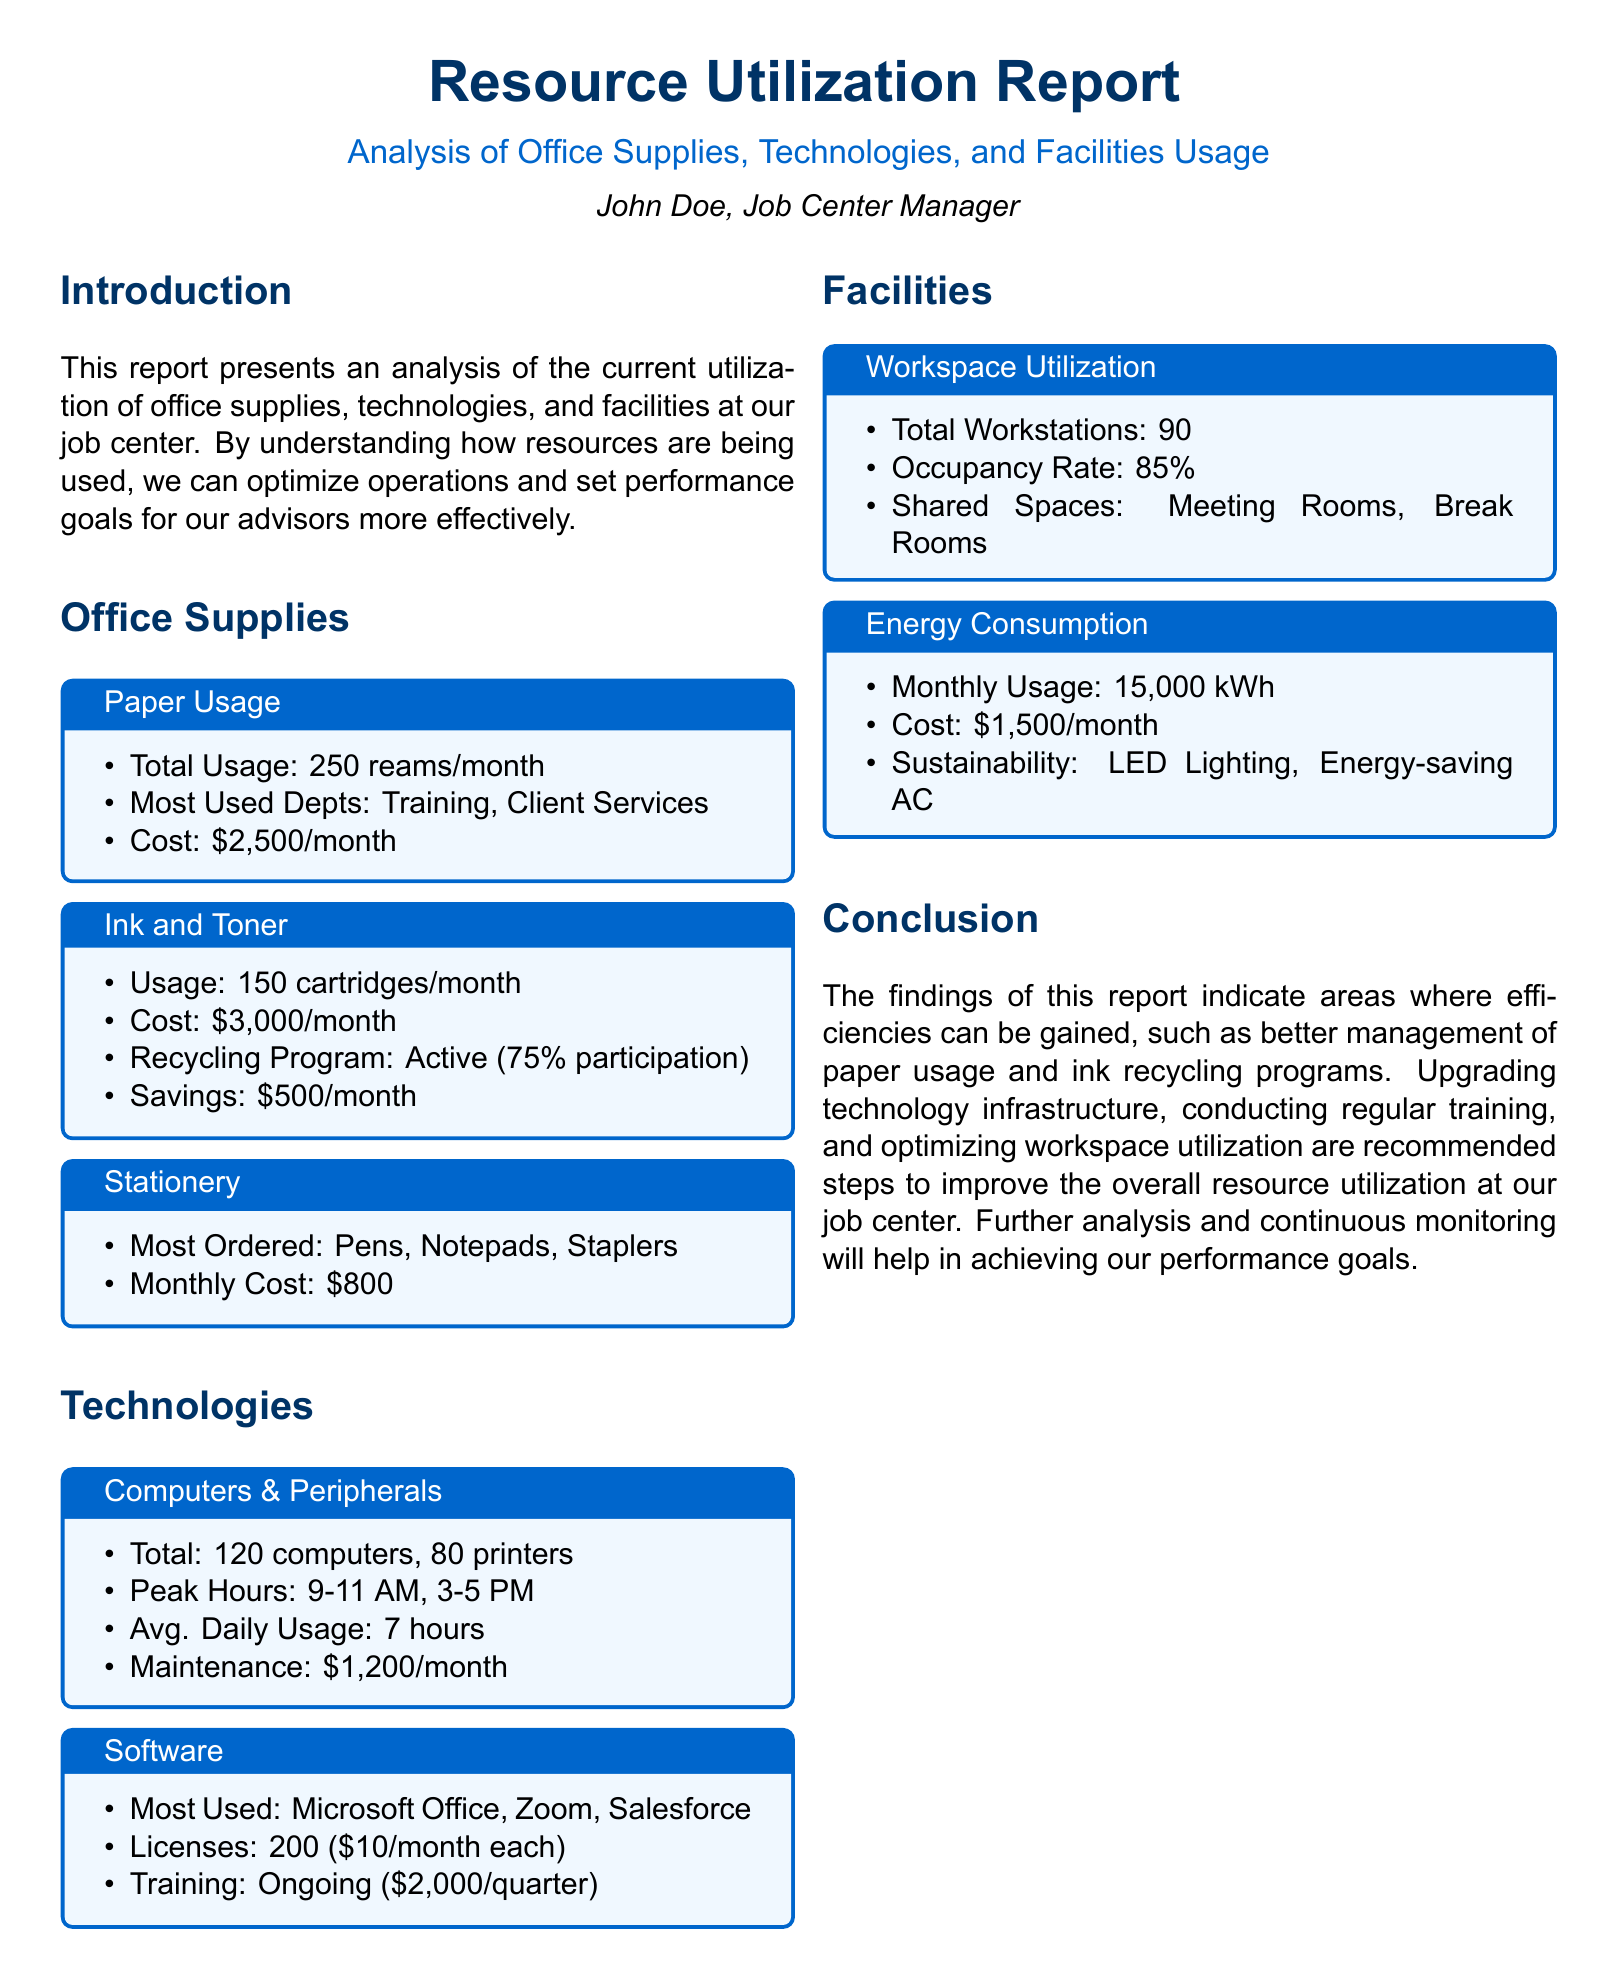what is the total paper usage? The total paper usage is noted as 250 reams per month.
Answer: 250 reams/month what is the cost of ink and toner per month? The document states that the cost of ink and toner is $3,000 per month.
Answer: $3,000/month which departments use the most paper? The report identifies Training and Client Services as the most used departments for paper.
Answer: Training, Client Services what is the average daily usage of computers? The average daily usage of computers is reported as 7 hours.
Answer: 7 hours what is the recycling program participation rate for ink and toner? The document indicates that the recycling program has a 75% participation rate.
Answer: 75% what is the current occupancy rate of workstations? The occupancy rate of workstations is specified as 85%.
Answer: 85% how many computers are totaled in the office? The report shows a total of 120 computers.
Answer: 120 computers what technologies are highlighted as most used? Microsoft Office, Zoom, Salesforce are highlighted as the most used technologies.
Answer: Microsoft Office, Zoom, Salesforce what is the monthly energy consumption cost? The monthly energy consumption cost is stated as $1,500 per month.
Answer: $1,500/month 